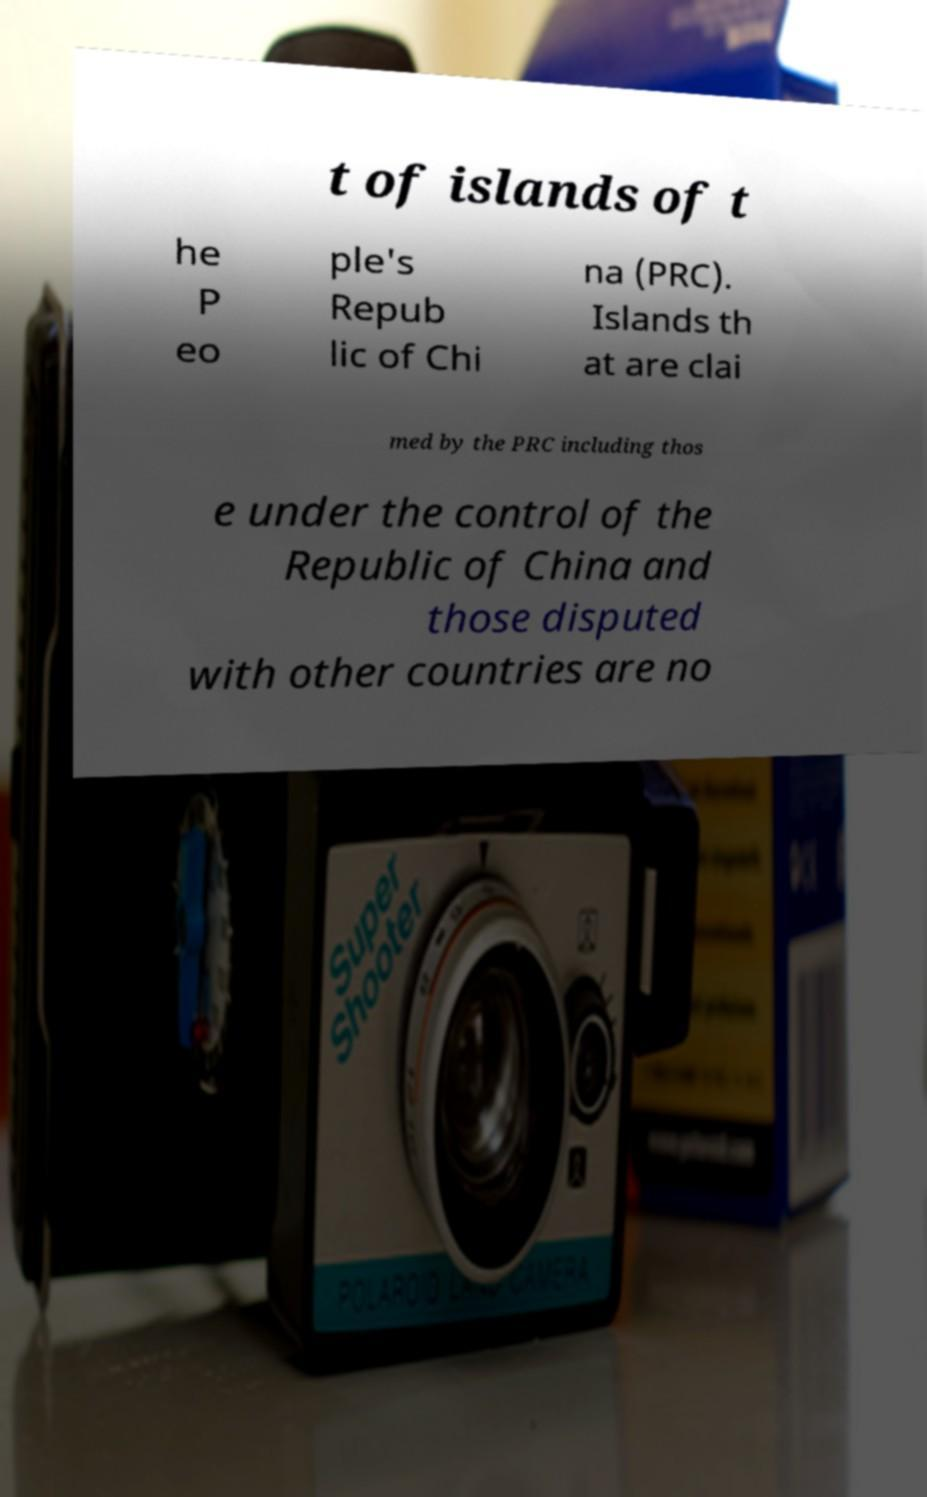I need the written content from this picture converted into text. Can you do that? t of islands of t he P eo ple's Repub lic of Chi na (PRC). Islands th at are clai med by the PRC including thos e under the control of the Republic of China and those disputed with other countries are no 